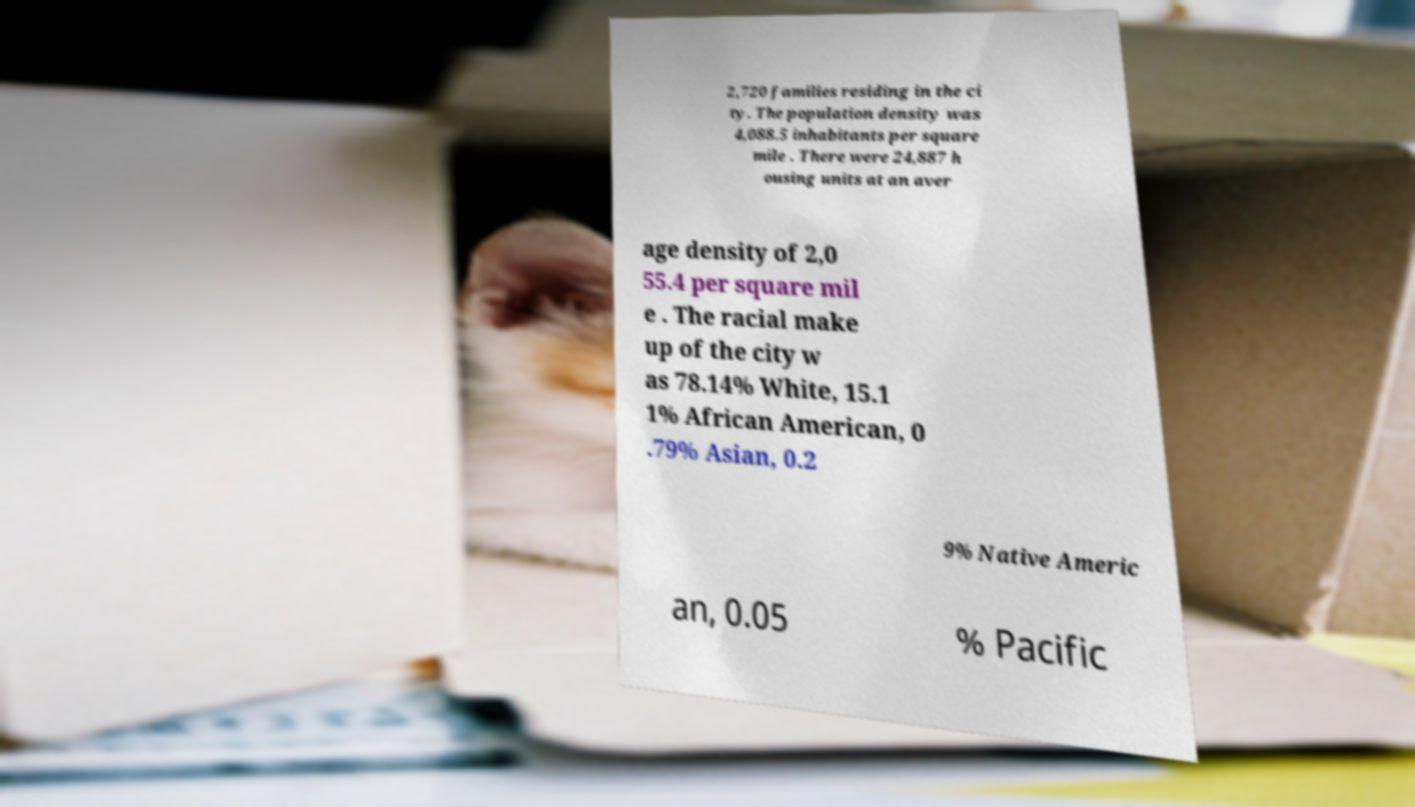I need the written content from this picture converted into text. Can you do that? 2,720 families residing in the ci ty. The population density was 4,088.5 inhabitants per square mile . There were 24,887 h ousing units at an aver age density of 2,0 55.4 per square mil e . The racial make up of the city w as 78.14% White, 15.1 1% African American, 0 .79% Asian, 0.2 9% Native Americ an, 0.05 % Pacific 